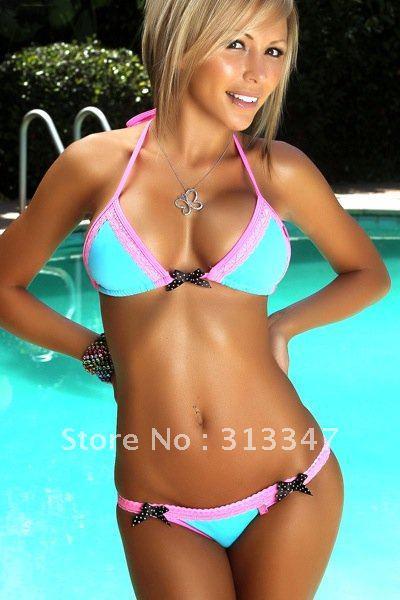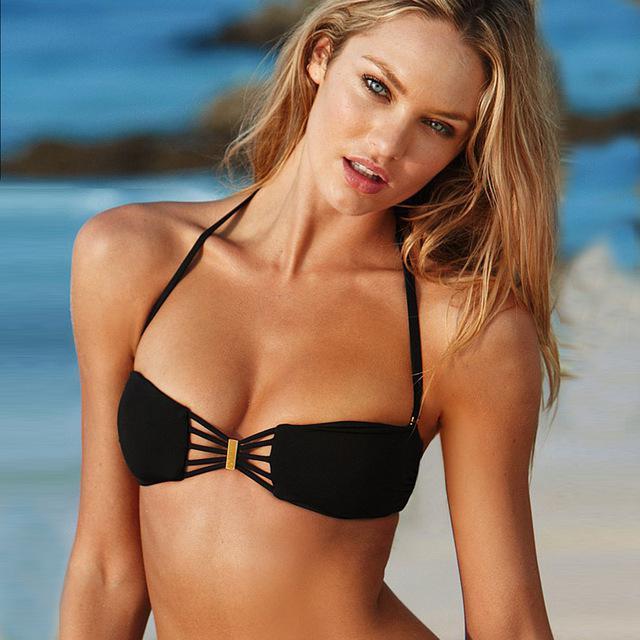The first image is the image on the left, the second image is the image on the right. Examine the images to the left and right. Is the description "An image shows a rear view of a bikini and a forward view." accurate? Answer yes or no. No. 